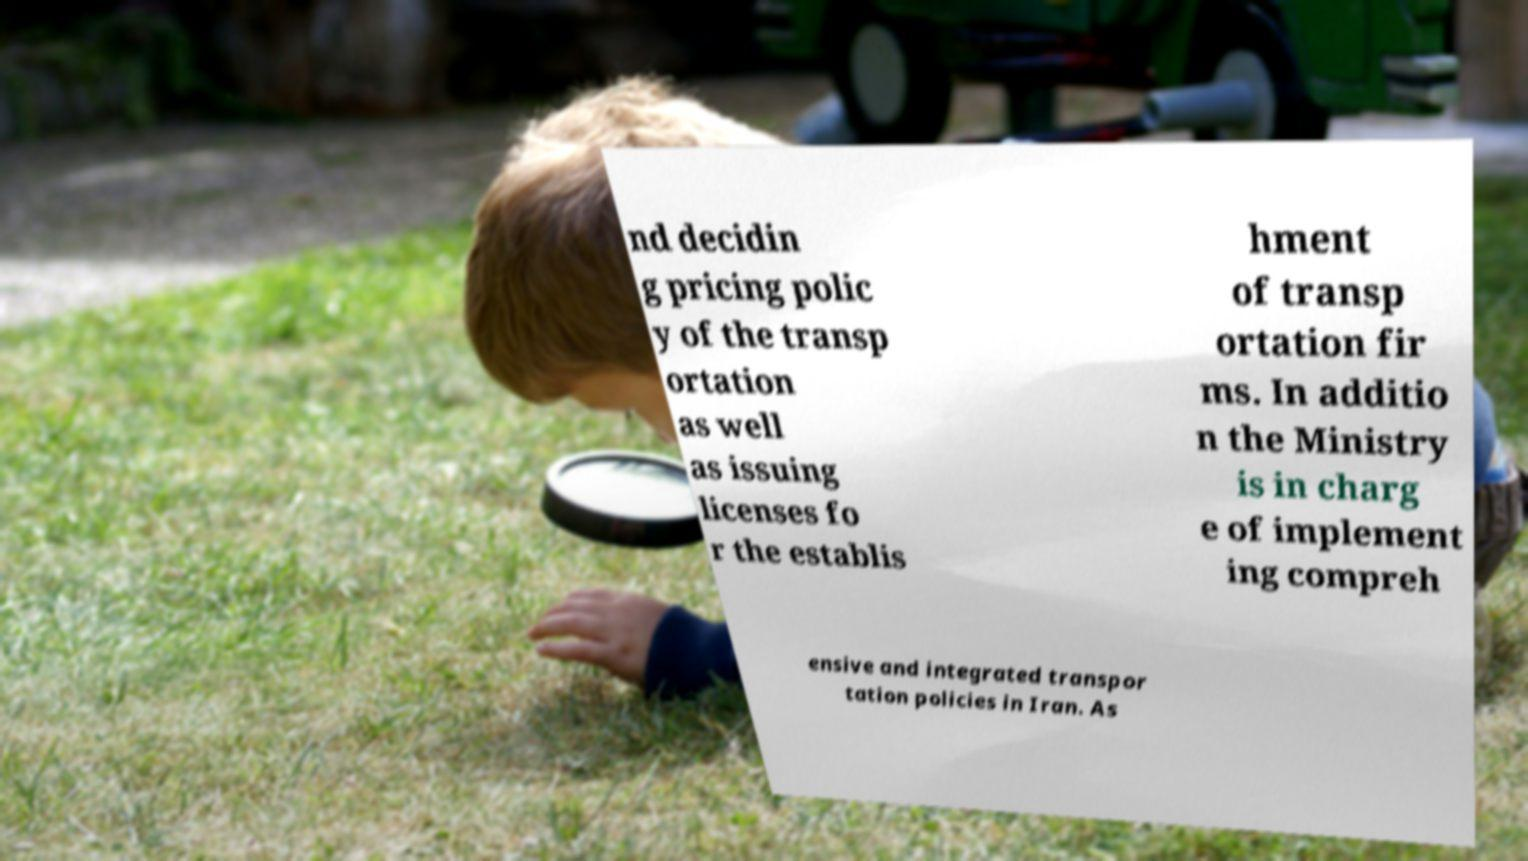What messages or text are displayed in this image? I need them in a readable, typed format. nd decidin g pricing polic y of the transp ortation as well as issuing licenses fo r the establis hment of transp ortation fir ms. In additio n the Ministry is in charg e of implement ing compreh ensive and integrated transpor tation policies in Iran. As 